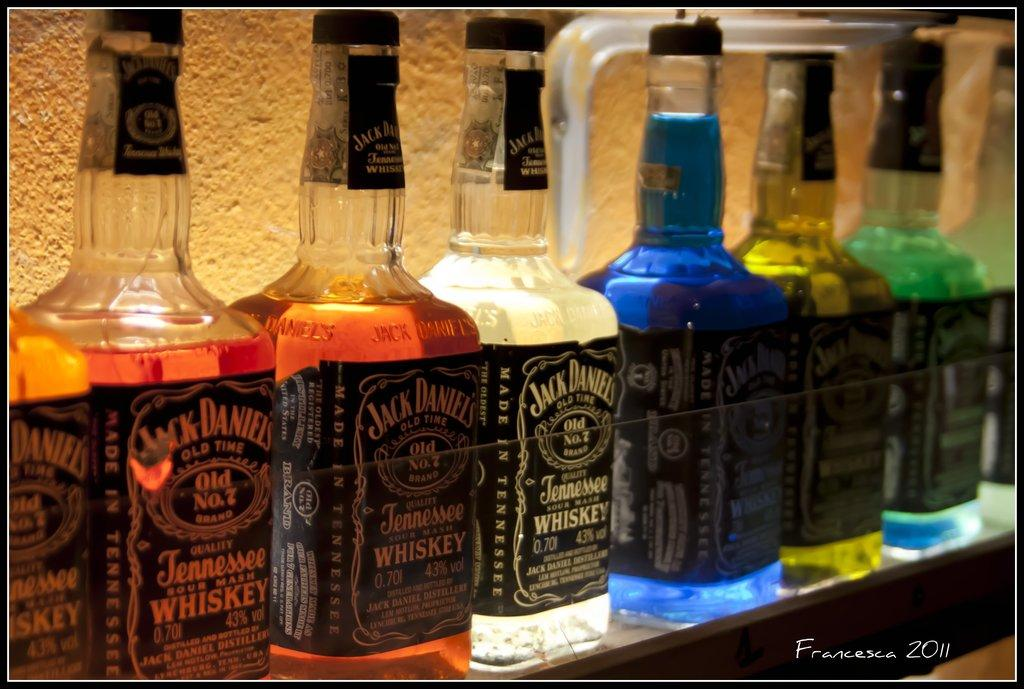Provide a one-sentence caption for the provided image. Bottles of hard liquor such as whiskey underneath lighting. 